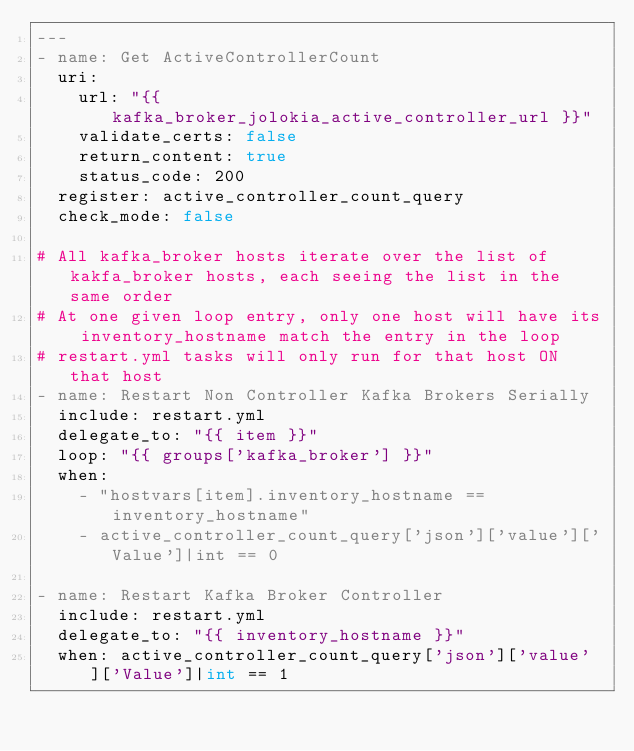<code> <loc_0><loc_0><loc_500><loc_500><_YAML_>---
- name: Get ActiveControllerCount
  uri:
    url: "{{ kafka_broker_jolokia_active_controller_url }}"
    validate_certs: false
    return_content: true
    status_code: 200
  register: active_controller_count_query
  check_mode: false

# All kafka_broker hosts iterate over the list of kakfa_broker hosts, each seeing the list in the same order
# At one given loop entry, only one host will have its inventory_hostname match the entry in the loop
# restart.yml tasks will only run for that host ON that host
- name: Restart Non Controller Kafka Brokers Serially
  include: restart.yml
  delegate_to: "{{ item }}"
  loop: "{{ groups['kafka_broker'] }}"
  when:
    - "hostvars[item].inventory_hostname == inventory_hostname"
    - active_controller_count_query['json']['value']['Value']|int == 0

- name: Restart Kafka Broker Controller
  include: restart.yml
  delegate_to: "{{ inventory_hostname }}"
  when: active_controller_count_query['json']['value']['Value']|int == 1
</code> 